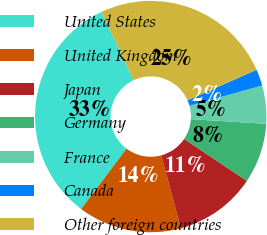<chart> <loc_0><loc_0><loc_500><loc_500><pie_chart><fcel>United States<fcel>United Kingdom<fcel>Japan<fcel>Germany<fcel>France<fcel>Canada<fcel>Other foreign countries<nl><fcel>32.73%<fcel>14.47%<fcel>11.42%<fcel>8.38%<fcel>5.34%<fcel>2.29%<fcel>25.37%<nl></chart> 